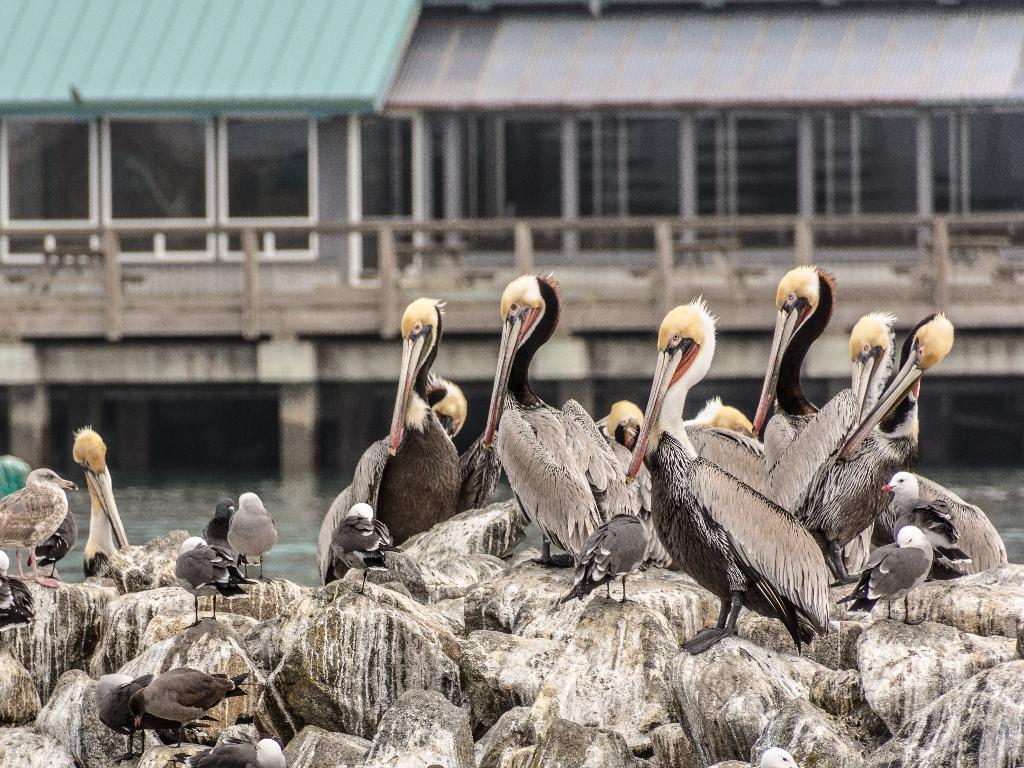Please provide a concise description of this image. In this picture I can see there are some birds sitting on the rocks here and there is a lake, a bridge and there are some buildings in the backdrop. 